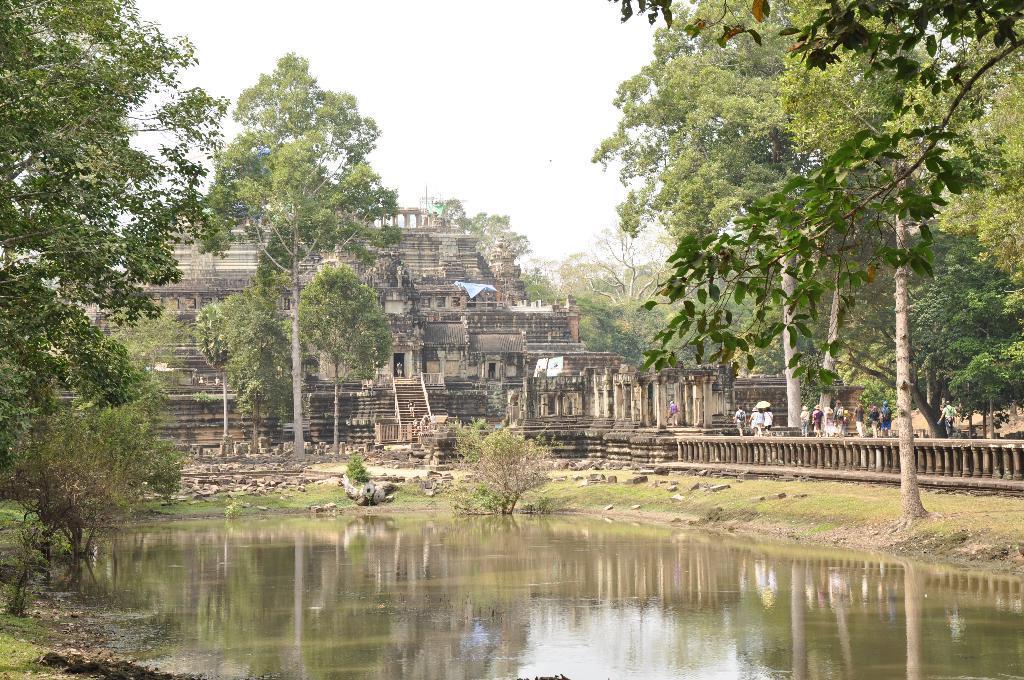Could you give a brief overview of what you see in this image? In this image I can see water in the front. I can also see number of trees, a building and number of people. In the background I can see the sky. 